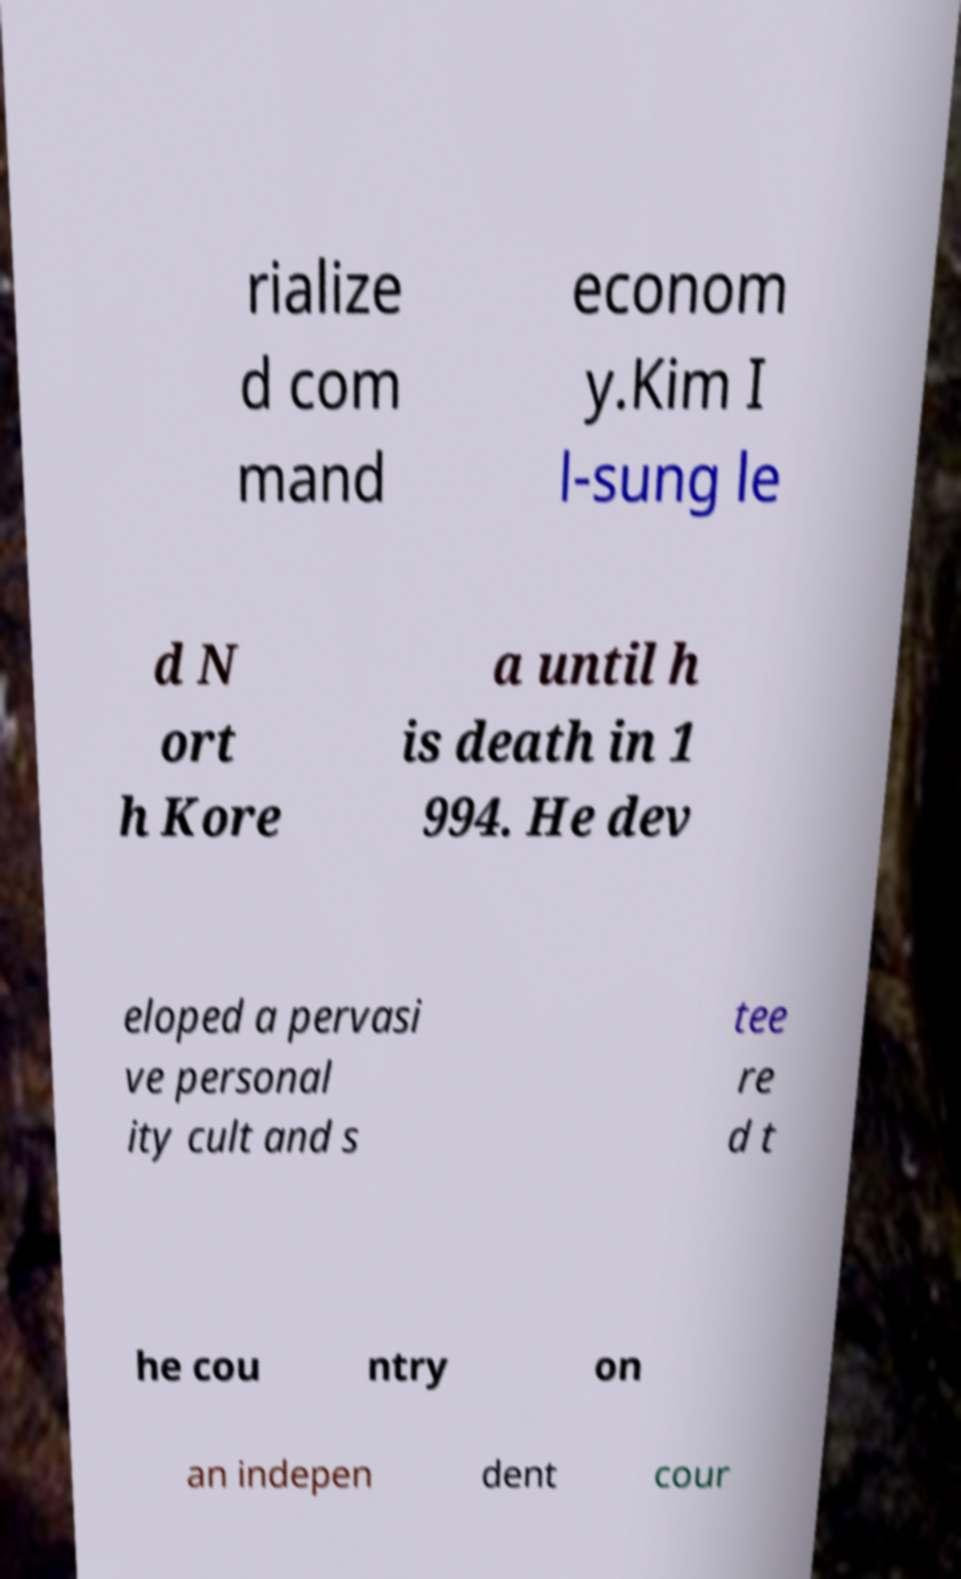What messages or text are displayed in this image? I need them in a readable, typed format. rialize d com mand econom y.Kim I l-sung le d N ort h Kore a until h is death in 1 994. He dev eloped a pervasi ve personal ity cult and s tee re d t he cou ntry on an indepen dent cour 